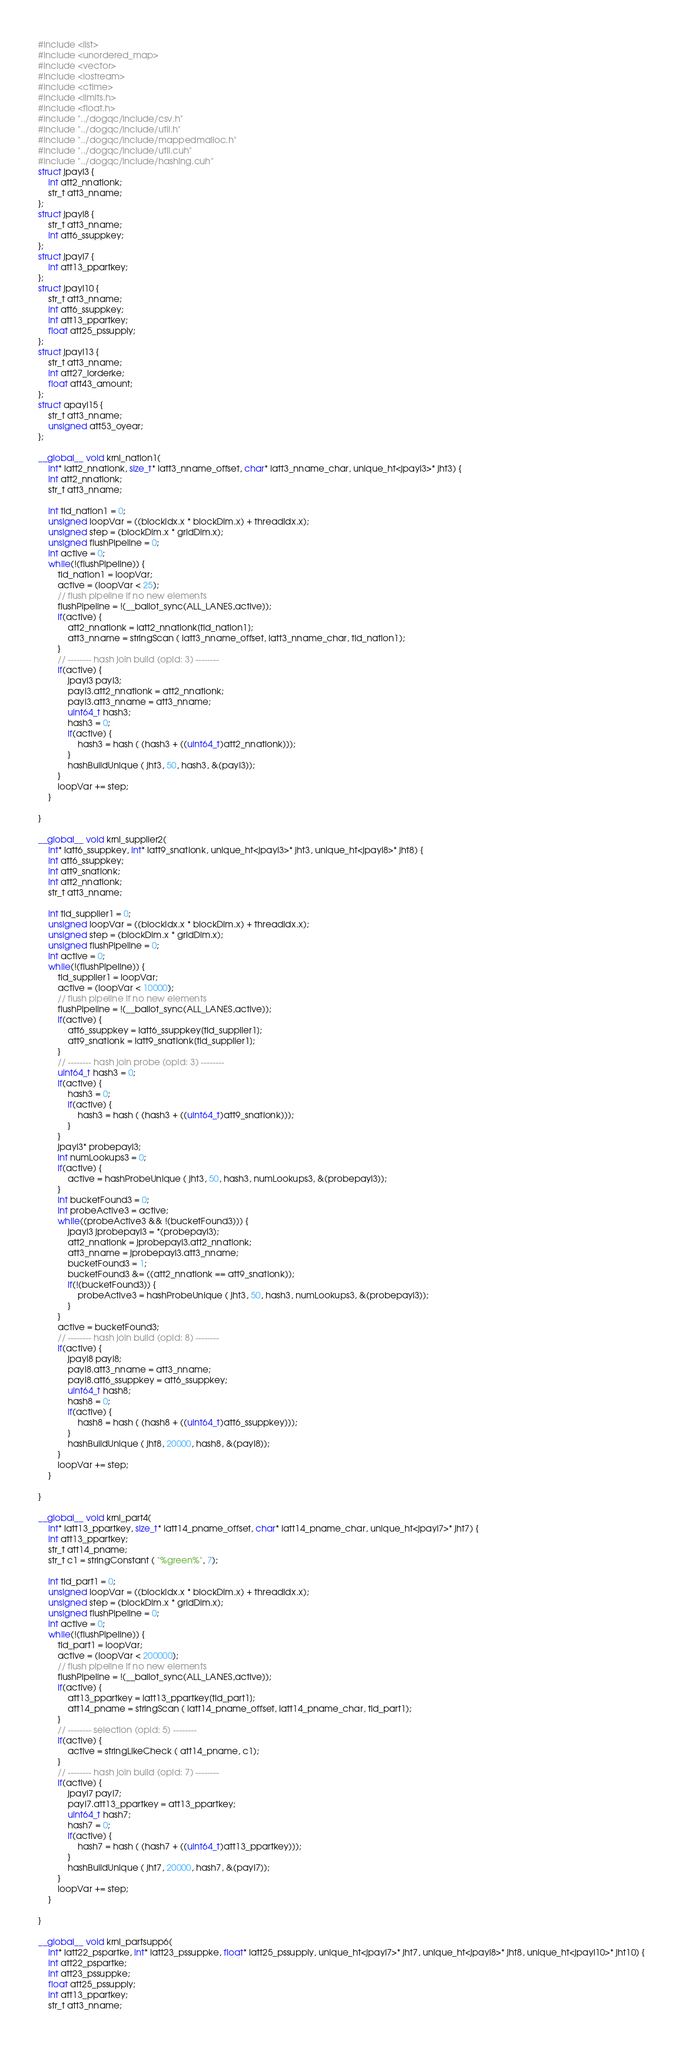Convert code to text. <code><loc_0><loc_0><loc_500><loc_500><_Cuda_>#include <list>
#include <unordered_map>
#include <vector>
#include <iostream>
#include <ctime>
#include <limits.h>
#include <float.h>
#include "../dogqc/include/csv.h"
#include "../dogqc/include/util.h"
#include "../dogqc/include/mappedmalloc.h"
#include "../dogqc/include/util.cuh"
#include "../dogqc/include/hashing.cuh"
struct jpayl3 {
    int att2_nnationk;
    str_t att3_nname;
};
struct jpayl8 {
    str_t att3_nname;
    int att6_ssuppkey;
};
struct jpayl7 {
    int att13_ppartkey;
};
struct jpayl10 {
    str_t att3_nname;
    int att6_ssuppkey;
    int att13_ppartkey;
    float att25_pssupply;
};
struct jpayl13 {
    str_t att3_nname;
    int att27_lorderke;
    float att43_amount;
};
struct apayl15 {
    str_t att3_nname;
    unsigned att53_oyear;
};

__global__ void krnl_nation1(
    int* iatt2_nnationk, size_t* iatt3_nname_offset, char* iatt3_nname_char, unique_ht<jpayl3>* jht3) {
    int att2_nnationk;
    str_t att3_nname;

    int tid_nation1 = 0;
    unsigned loopVar = ((blockIdx.x * blockDim.x) + threadIdx.x);
    unsigned step = (blockDim.x * gridDim.x);
    unsigned flushPipeline = 0;
    int active = 0;
    while(!(flushPipeline)) {
        tid_nation1 = loopVar;
        active = (loopVar < 25);
        // flush pipeline if no new elements
        flushPipeline = !(__ballot_sync(ALL_LANES,active));
        if(active) {
            att2_nnationk = iatt2_nnationk[tid_nation1];
            att3_nname = stringScan ( iatt3_nname_offset, iatt3_nname_char, tid_nation1);
        }
        // -------- hash join build (opId: 3) --------
        if(active) {
            jpayl3 payl3;
            payl3.att2_nnationk = att2_nnationk;
            payl3.att3_nname = att3_nname;
            uint64_t hash3;
            hash3 = 0;
            if(active) {
                hash3 = hash ( (hash3 + ((uint64_t)att2_nnationk)));
            }
            hashBuildUnique ( jht3, 50, hash3, &(payl3));
        }
        loopVar += step;
    }

}

__global__ void krnl_supplier2(
    int* iatt6_ssuppkey, int* iatt9_snationk, unique_ht<jpayl3>* jht3, unique_ht<jpayl8>* jht8) {
    int att6_ssuppkey;
    int att9_snationk;
    int att2_nnationk;
    str_t att3_nname;

    int tid_supplier1 = 0;
    unsigned loopVar = ((blockIdx.x * blockDim.x) + threadIdx.x);
    unsigned step = (blockDim.x * gridDim.x);
    unsigned flushPipeline = 0;
    int active = 0;
    while(!(flushPipeline)) {
        tid_supplier1 = loopVar;
        active = (loopVar < 10000);
        // flush pipeline if no new elements
        flushPipeline = !(__ballot_sync(ALL_LANES,active));
        if(active) {
            att6_ssuppkey = iatt6_ssuppkey[tid_supplier1];
            att9_snationk = iatt9_snationk[tid_supplier1];
        }
        // -------- hash join probe (opId: 3) --------
        uint64_t hash3 = 0;
        if(active) {
            hash3 = 0;
            if(active) {
                hash3 = hash ( (hash3 + ((uint64_t)att9_snationk)));
            }
        }
        jpayl3* probepayl3;
        int numLookups3 = 0;
        if(active) {
            active = hashProbeUnique ( jht3, 50, hash3, numLookups3, &(probepayl3));
        }
        int bucketFound3 = 0;
        int probeActive3 = active;
        while((probeActive3 && !(bucketFound3))) {
            jpayl3 jprobepayl3 = *(probepayl3);
            att2_nnationk = jprobepayl3.att2_nnationk;
            att3_nname = jprobepayl3.att3_nname;
            bucketFound3 = 1;
            bucketFound3 &= ((att2_nnationk == att9_snationk));
            if(!(bucketFound3)) {
                probeActive3 = hashProbeUnique ( jht3, 50, hash3, numLookups3, &(probepayl3));
            }
        }
        active = bucketFound3;
        // -------- hash join build (opId: 8) --------
        if(active) {
            jpayl8 payl8;
            payl8.att3_nname = att3_nname;
            payl8.att6_ssuppkey = att6_ssuppkey;
            uint64_t hash8;
            hash8 = 0;
            if(active) {
                hash8 = hash ( (hash8 + ((uint64_t)att6_ssuppkey)));
            }
            hashBuildUnique ( jht8, 20000, hash8, &(payl8));
        }
        loopVar += step;
    }

}

__global__ void krnl_part4(
    int* iatt13_ppartkey, size_t* iatt14_pname_offset, char* iatt14_pname_char, unique_ht<jpayl7>* jht7) {
    int att13_ppartkey;
    str_t att14_pname;
    str_t c1 = stringConstant ( "%green%", 7);

    int tid_part1 = 0;
    unsigned loopVar = ((blockIdx.x * blockDim.x) + threadIdx.x);
    unsigned step = (blockDim.x * gridDim.x);
    unsigned flushPipeline = 0;
    int active = 0;
    while(!(flushPipeline)) {
        tid_part1 = loopVar;
        active = (loopVar < 200000);
        // flush pipeline if no new elements
        flushPipeline = !(__ballot_sync(ALL_LANES,active));
        if(active) {
            att13_ppartkey = iatt13_ppartkey[tid_part1];
            att14_pname = stringScan ( iatt14_pname_offset, iatt14_pname_char, tid_part1);
        }
        // -------- selection (opId: 5) --------
        if(active) {
            active = stringLikeCheck ( att14_pname, c1);
        }
        // -------- hash join build (opId: 7) --------
        if(active) {
            jpayl7 payl7;
            payl7.att13_ppartkey = att13_ppartkey;
            uint64_t hash7;
            hash7 = 0;
            if(active) {
                hash7 = hash ( (hash7 + ((uint64_t)att13_ppartkey)));
            }
            hashBuildUnique ( jht7, 20000, hash7, &(payl7));
        }
        loopVar += step;
    }

}

__global__ void krnl_partsupp6(
    int* iatt22_pspartke, int* iatt23_pssuppke, float* iatt25_pssupply, unique_ht<jpayl7>* jht7, unique_ht<jpayl8>* jht8, unique_ht<jpayl10>* jht10) {
    int att22_pspartke;
    int att23_pssuppke;
    float att25_pssupply;
    int att13_ppartkey;
    str_t att3_nname;</code> 